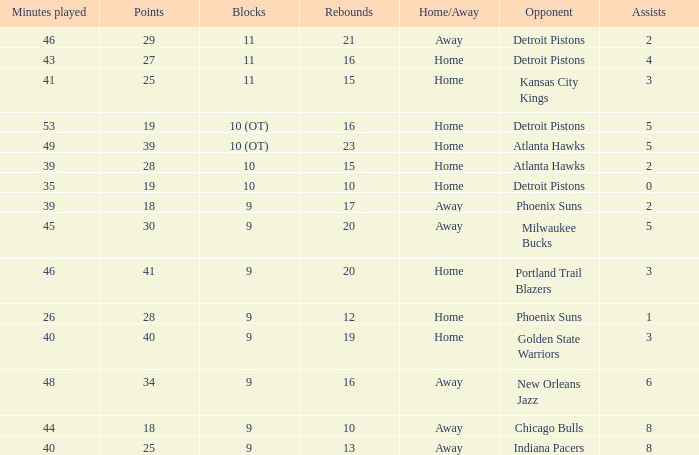How many points were there when there were less than 16 rebounds and 5 assists? 0.0. 